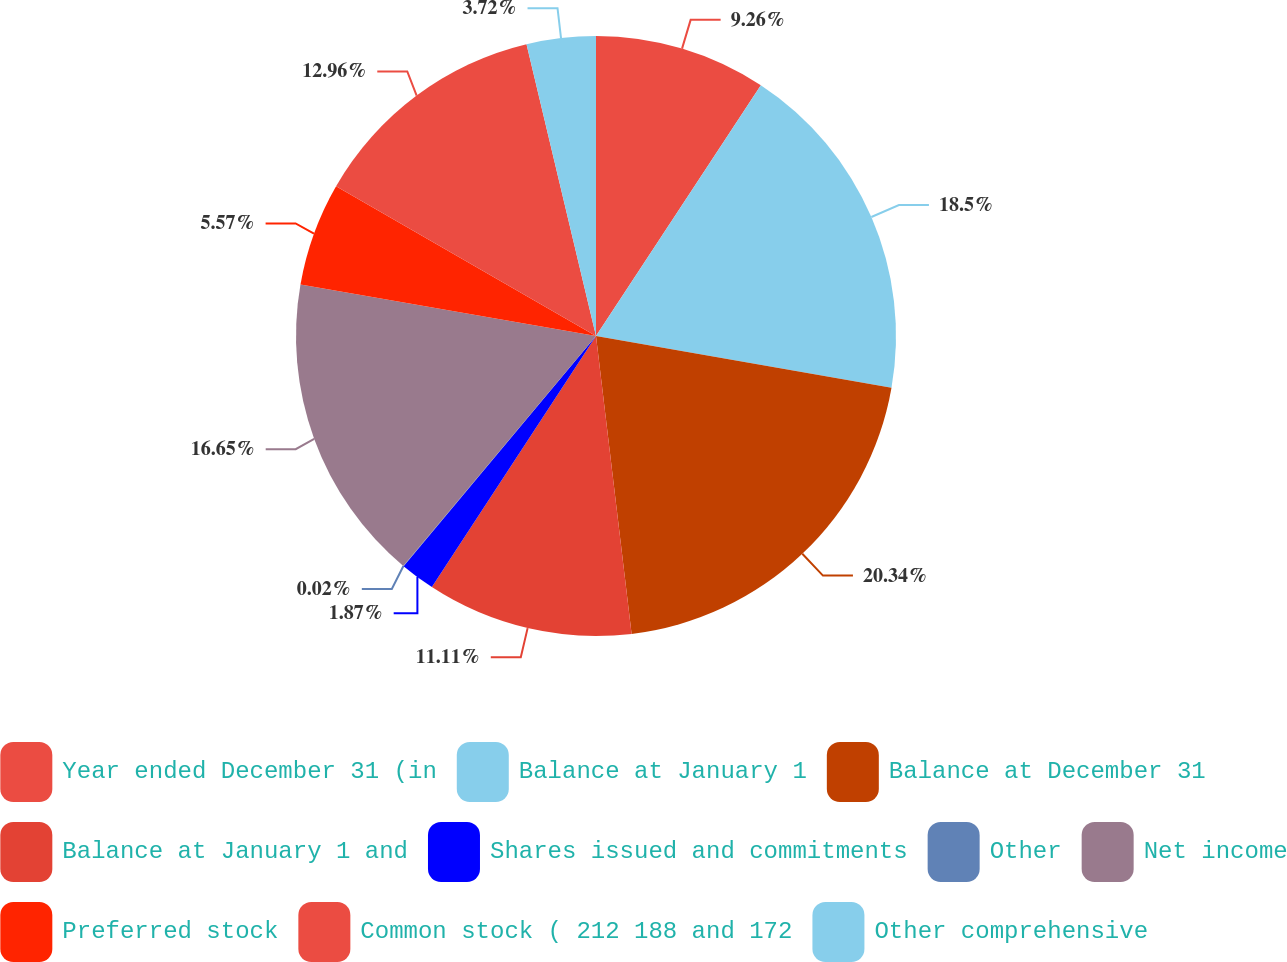Convert chart. <chart><loc_0><loc_0><loc_500><loc_500><pie_chart><fcel>Year ended December 31 (in<fcel>Balance at January 1<fcel>Balance at December 31<fcel>Balance at January 1 and<fcel>Shares issued and commitments<fcel>Other<fcel>Net income<fcel>Preferred stock<fcel>Common stock ( 212 188 and 172<fcel>Other comprehensive<nl><fcel>9.26%<fcel>18.5%<fcel>20.35%<fcel>11.11%<fcel>1.87%<fcel>0.02%<fcel>16.65%<fcel>5.57%<fcel>12.96%<fcel>3.72%<nl></chart> 